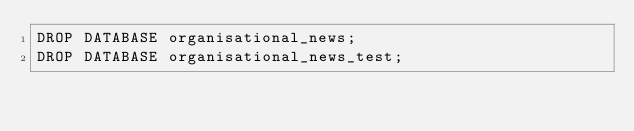<code> <loc_0><loc_0><loc_500><loc_500><_SQL_>DROP DATABASE organisational_news;
DROP DATABASE organisational_news_test;</code> 